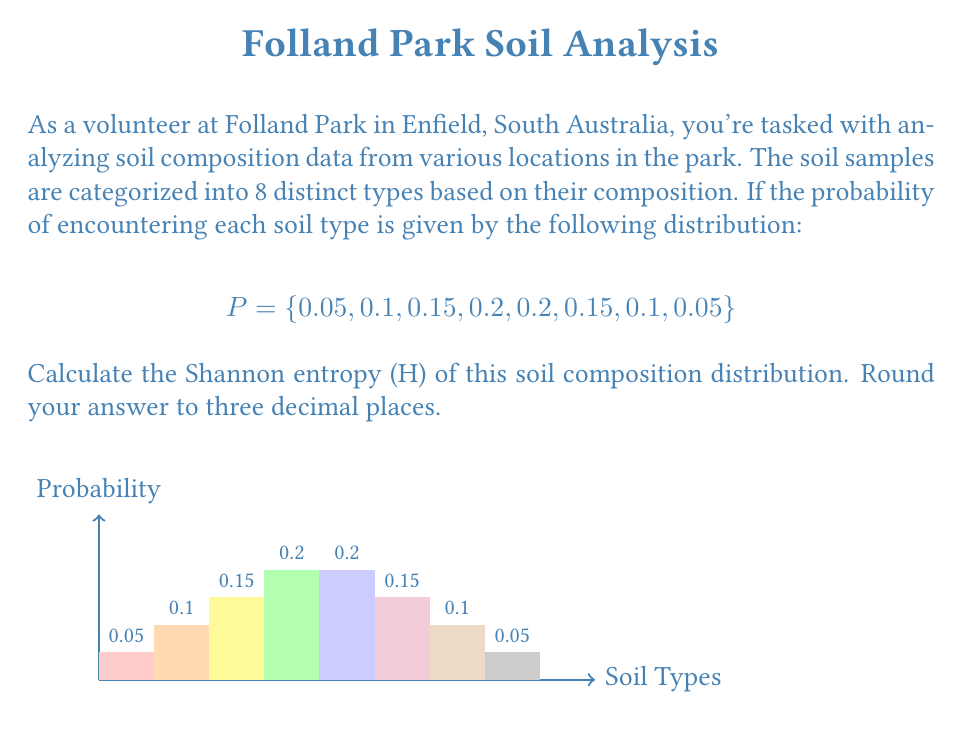Solve this math problem. To calculate the Shannon entropy (H) of the soil composition distribution, we'll use the formula:

$$H = -\sum_{i=1}^{n} p_i \log_2(p_i)$$

Where $p_i$ is the probability of each soil type, and $n$ is the number of soil types (8 in this case).

Let's calculate each term:

1) $-0.05 \log_2(0.05) = 0.2161859$
2) $-0.1 \log_2(0.1) = 0.3321928$
3) $-0.15 \log_2(0.15) = 0.4105144$
4) $-0.2 \log_2(0.2) = 0.4643856$
5) $-0.2 \log_2(0.2) = 0.4643856$
6) $-0.15 \log_2(0.15) = 0.4105144$
7) $-0.1 \log_2(0.1) = 0.3321928$
8) $-0.05 \log_2(0.05) = 0.2161859$

Now, we sum all these terms:

$$H = 0.2161859 + 0.3321928 + 0.4105144 + 0.4643856 + 0.4643856 + 0.4105144 + 0.3321928 + 0.2161859$$

$$H = 2.8465574$$

Rounding to three decimal places:

$$H \approx 2.847$$

This value represents the average amount of information contained in the soil composition distribution. A higher value indicates more diversity in soil types.
Answer: 2.847 bits 